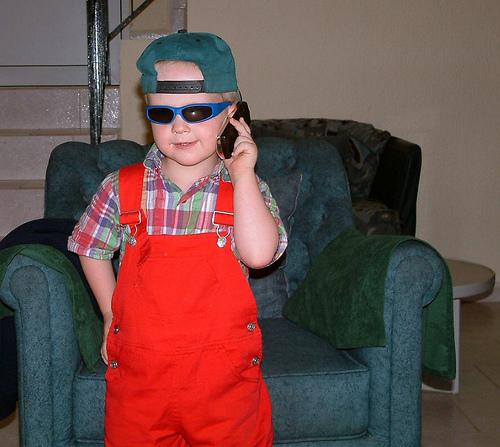Is this kid cool?
Quick response, please. Yes. What is blue?
Answer briefly. Chair. What color overalls are shown?
Concise answer only. Red. What color is the chair?
Quick response, please. Blue. What is this child standing in front of?
Short answer required. Chair. 